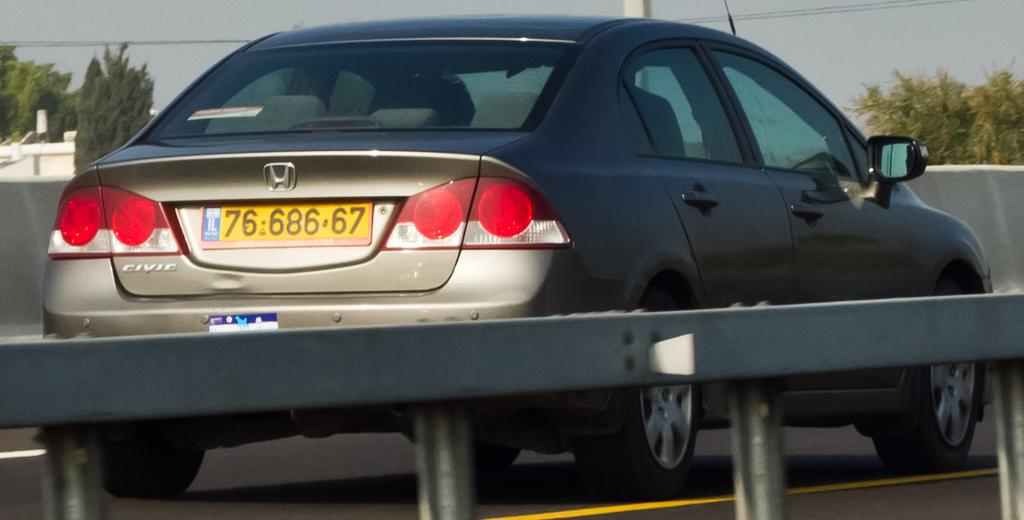<image>
Render a clear and concise summary of the photo. The licence plate number of the Honda Civic is 76-686-67. 